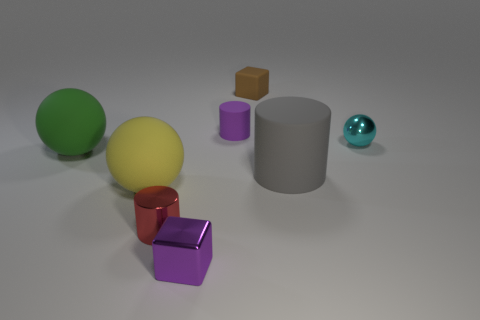Subtract all big cylinders. How many cylinders are left? 2 Add 1 tiny metallic spheres. How many objects exist? 9 Subtract all green cylinders. Subtract all cyan spheres. How many cylinders are left? 3 Subtract all spheres. How many objects are left? 5 Add 2 tiny cyan cylinders. How many tiny cyan cylinders exist? 2 Subtract 1 purple cylinders. How many objects are left? 7 Subtract all large rubber objects. Subtract all small matte things. How many objects are left? 3 Add 4 brown blocks. How many brown blocks are left? 5 